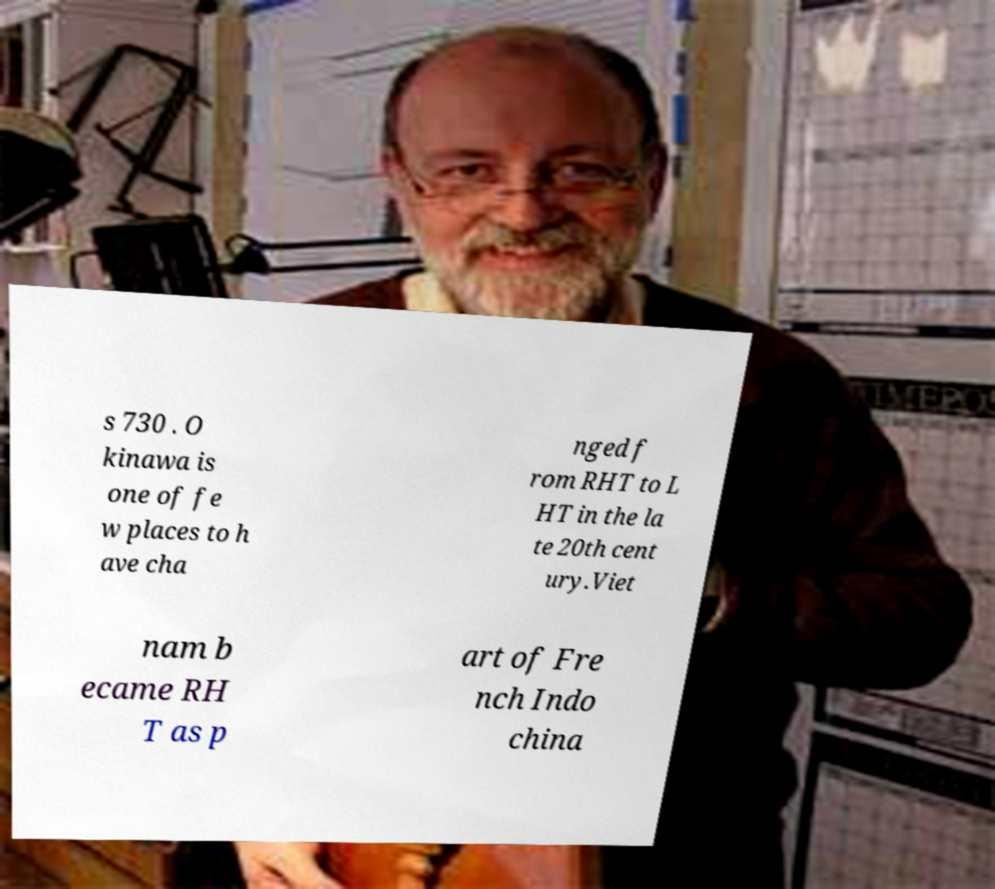I need the written content from this picture converted into text. Can you do that? s 730 . O kinawa is one of fe w places to h ave cha nged f rom RHT to L HT in the la te 20th cent ury.Viet nam b ecame RH T as p art of Fre nch Indo china 